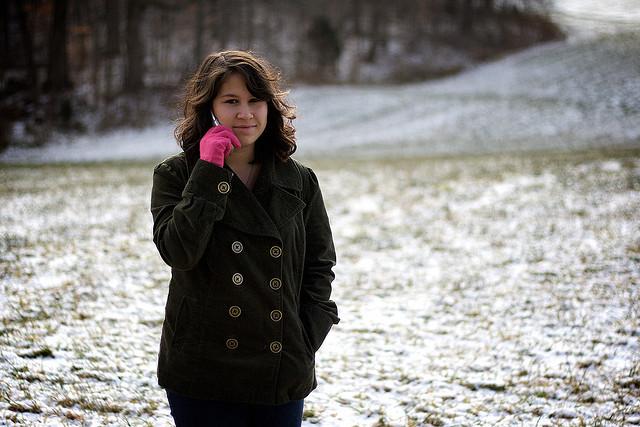How many buttons on the coat?
Give a very brief answer. 9. Is the ground wet?
Answer briefly. Yes. What temperature sensation is the woman feeling on her face?
Be succinct. Cold. Is anything hanging from this ladies arm?
Answer briefly. No. 